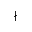Convert formula to latex. <formula><loc_0><loc_0><loc_500><loc_500>\nmid</formula> 